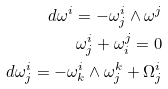Convert formula to latex. <formula><loc_0><loc_0><loc_500><loc_500>d \omega ^ { i } = - \omega ^ { i } _ { j } \wedge \omega ^ { j } \\ \omega _ { j } ^ { i } + \omega _ { i } ^ { j } = 0 \\ d \omega ^ { i } _ { j } = - \omega ^ { i } _ { k } \wedge \omega ^ { k } _ { j } + \Omega _ { j } ^ { i }</formula> 